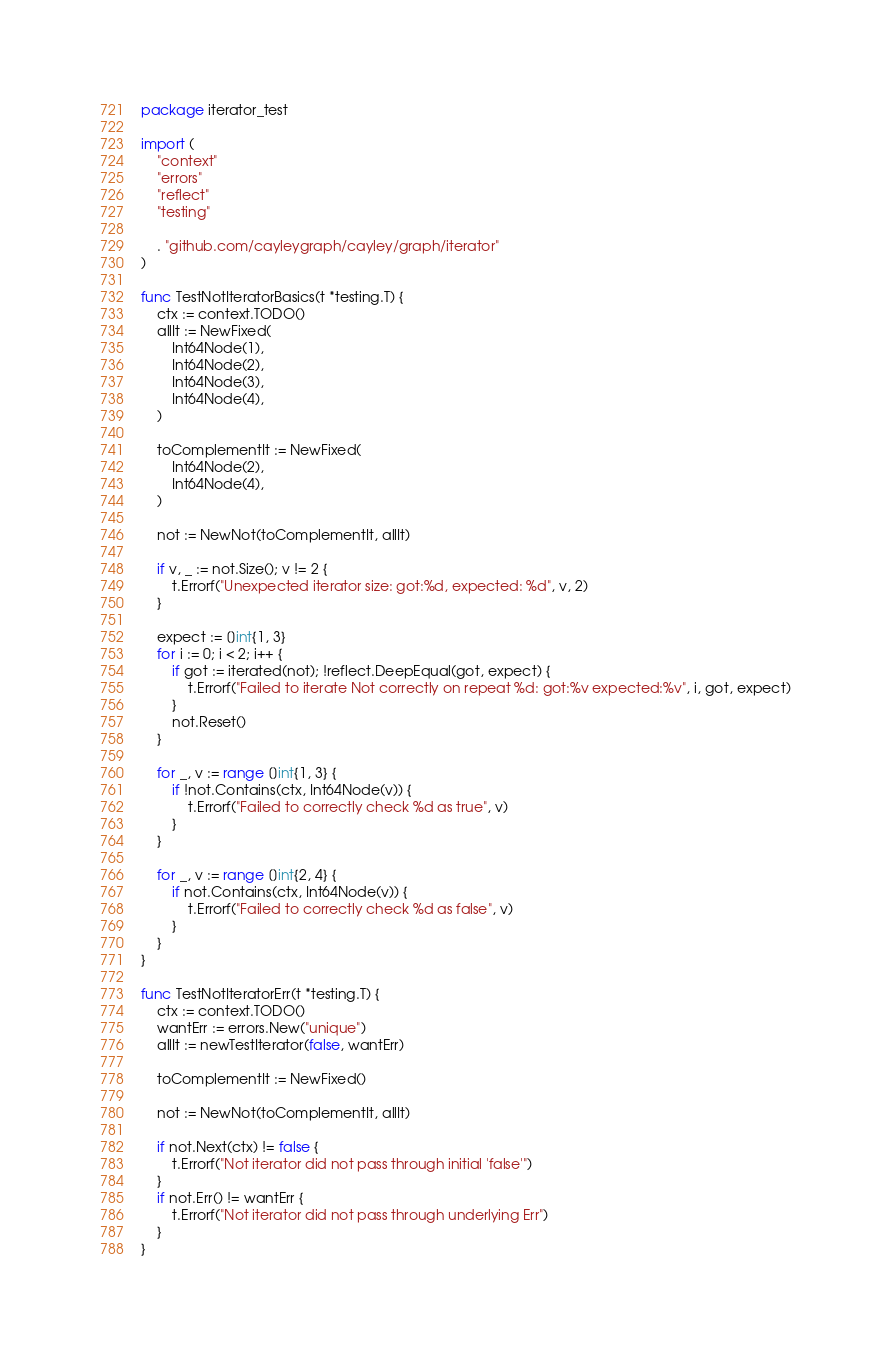Convert code to text. <code><loc_0><loc_0><loc_500><loc_500><_Go_>package iterator_test

import (
	"context"
	"errors"
	"reflect"
	"testing"

	. "github.com/cayleygraph/cayley/graph/iterator"
)

func TestNotIteratorBasics(t *testing.T) {
	ctx := context.TODO()
	allIt := NewFixed(
		Int64Node(1),
		Int64Node(2),
		Int64Node(3),
		Int64Node(4),
	)

	toComplementIt := NewFixed(
		Int64Node(2),
		Int64Node(4),
	)

	not := NewNot(toComplementIt, allIt)

	if v, _ := not.Size(); v != 2 {
		t.Errorf("Unexpected iterator size: got:%d, expected: %d", v, 2)
	}

	expect := []int{1, 3}
	for i := 0; i < 2; i++ {
		if got := iterated(not); !reflect.DeepEqual(got, expect) {
			t.Errorf("Failed to iterate Not correctly on repeat %d: got:%v expected:%v", i, got, expect)
		}
		not.Reset()
	}

	for _, v := range []int{1, 3} {
		if !not.Contains(ctx, Int64Node(v)) {
			t.Errorf("Failed to correctly check %d as true", v)
		}
	}

	for _, v := range []int{2, 4} {
		if not.Contains(ctx, Int64Node(v)) {
			t.Errorf("Failed to correctly check %d as false", v)
		}
	}
}

func TestNotIteratorErr(t *testing.T) {
	ctx := context.TODO()
	wantErr := errors.New("unique")
	allIt := newTestIterator(false, wantErr)

	toComplementIt := NewFixed()

	not := NewNot(toComplementIt, allIt)

	if not.Next(ctx) != false {
		t.Errorf("Not iterator did not pass through initial 'false'")
	}
	if not.Err() != wantErr {
		t.Errorf("Not iterator did not pass through underlying Err")
	}
}
</code> 